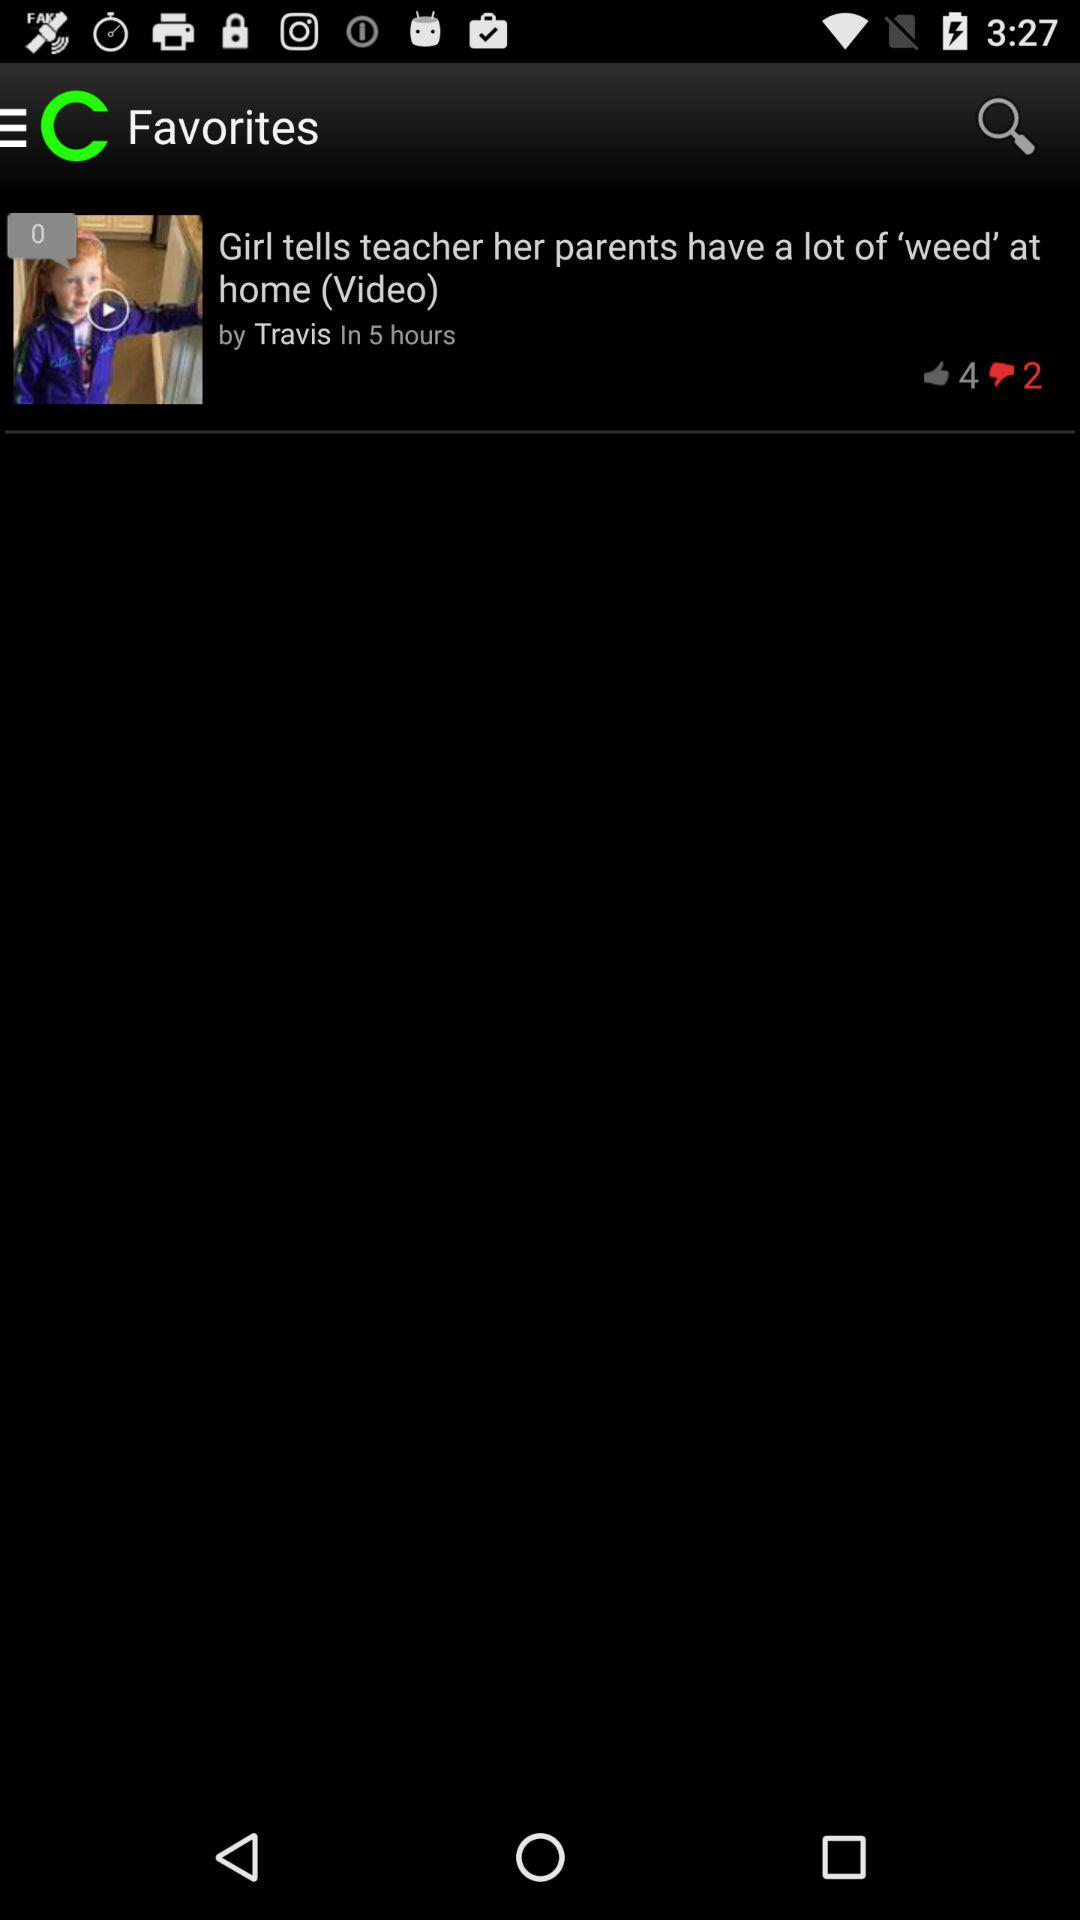How many dislikes are on this video? There are 2 dislikes. 